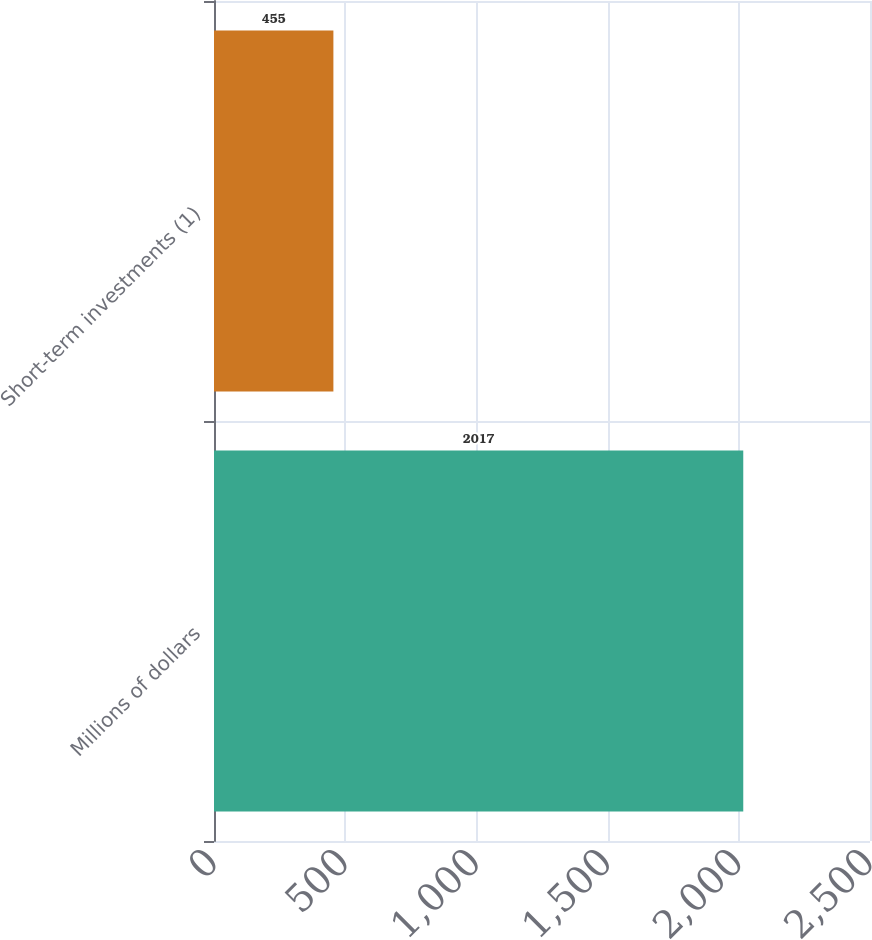Convert chart. <chart><loc_0><loc_0><loc_500><loc_500><bar_chart><fcel>Millions of dollars<fcel>Short-term investments (1)<nl><fcel>2017<fcel>455<nl></chart> 